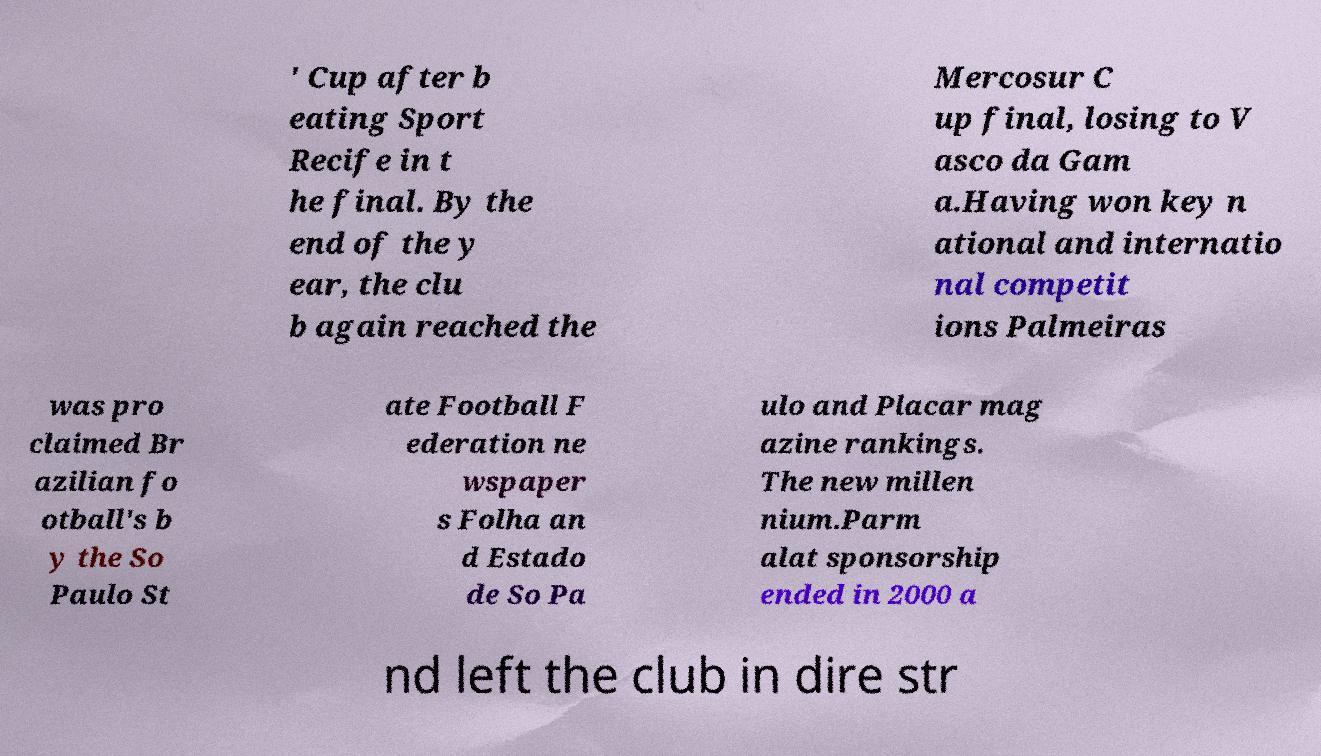Please read and relay the text visible in this image. What does it say? ' Cup after b eating Sport Recife in t he final. By the end of the y ear, the clu b again reached the Mercosur C up final, losing to V asco da Gam a.Having won key n ational and internatio nal competit ions Palmeiras was pro claimed Br azilian fo otball's b y the So Paulo St ate Football F ederation ne wspaper s Folha an d Estado de So Pa ulo and Placar mag azine rankings. The new millen nium.Parm alat sponsorship ended in 2000 a nd left the club in dire str 